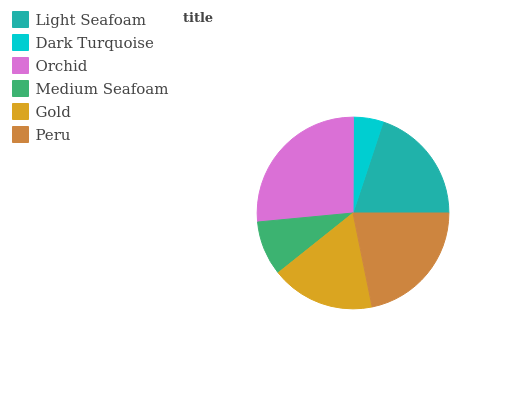Is Dark Turquoise the minimum?
Answer yes or no. Yes. Is Orchid the maximum?
Answer yes or no. Yes. Is Orchid the minimum?
Answer yes or no. No. Is Dark Turquoise the maximum?
Answer yes or no. No. Is Orchid greater than Dark Turquoise?
Answer yes or no. Yes. Is Dark Turquoise less than Orchid?
Answer yes or no. Yes. Is Dark Turquoise greater than Orchid?
Answer yes or no. No. Is Orchid less than Dark Turquoise?
Answer yes or no. No. Is Light Seafoam the high median?
Answer yes or no. Yes. Is Gold the low median?
Answer yes or no. Yes. Is Peru the high median?
Answer yes or no. No. Is Dark Turquoise the low median?
Answer yes or no. No. 